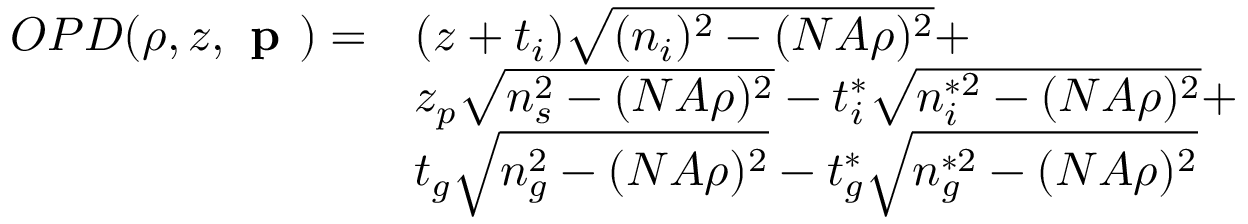<formula> <loc_0><loc_0><loc_500><loc_500>\begin{array} { c l } { O P D ( \rho , z , p ) = } & { ( z + t _ { i } ) \sqrt { ( n _ { i } ) ^ { 2 } - ( N A \rho ) ^ { 2 } } + } \\ & { z _ { p } \sqrt { n _ { s } ^ { 2 } - ( N A \rho ) ^ { 2 } } - t _ { i } ^ { * } \sqrt { n _ { i } ^ { * 2 } - ( N A \rho ) ^ { 2 } } + } \\ & { t _ { g } \sqrt { n _ { g } ^ { 2 } - ( N A \rho ) ^ { 2 } } - t _ { g } ^ { * } \sqrt { n _ { g } ^ { * 2 } - ( N A \rho ) ^ { 2 } } } \end{array}</formula> 